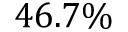Convert formula to latex. <formula><loc_0><loc_0><loc_500><loc_500>4 6 . 7 \%</formula> 